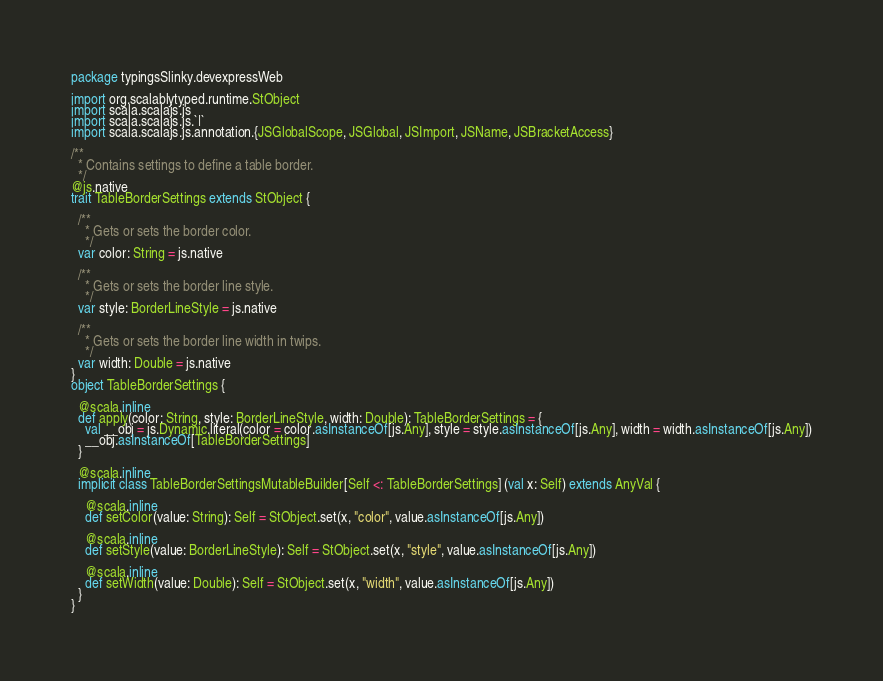<code> <loc_0><loc_0><loc_500><loc_500><_Scala_>package typingsSlinky.devexpressWeb

import org.scalablytyped.runtime.StObject
import scala.scalajs.js
import scala.scalajs.js.`|`
import scala.scalajs.js.annotation.{JSGlobalScope, JSGlobal, JSImport, JSName, JSBracketAccess}

/**
  * Contains settings to define a table border.
  */
@js.native
trait TableBorderSettings extends StObject {
  
  /**
    * Gets or sets the border color.
    */
  var color: String = js.native
  
  /**
    * Gets or sets the border line style.
    */
  var style: BorderLineStyle = js.native
  
  /**
    * Gets or sets the border line width in twips.
    */
  var width: Double = js.native
}
object TableBorderSettings {
  
  @scala.inline
  def apply(color: String, style: BorderLineStyle, width: Double): TableBorderSettings = {
    val __obj = js.Dynamic.literal(color = color.asInstanceOf[js.Any], style = style.asInstanceOf[js.Any], width = width.asInstanceOf[js.Any])
    __obj.asInstanceOf[TableBorderSettings]
  }
  
  @scala.inline
  implicit class TableBorderSettingsMutableBuilder[Self <: TableBorderSettings] (val x: Self) extends AnyVal {
    
    @scala.inline
    def setColor(value: String): Self = StObject.set(x, "color", value.asInstanceOf[js.Any])
    
    @scala.inline
    def setStyle(value: BorderLineStyle): Self = StObject.set(x, "style", value.asInstanceOf[js.Any])
    
    @scala.inline
    def setWidth(value: Double): Self = StObject.set(x, "width", value.asInstanceOf[js.Any])
  }
}
</code> 